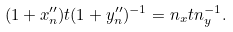Convert formula to latex. <formula><loc_0><loc_0><loc_500><loc_500>( 1 + x _ { n } ^ { \prime \prime } ) t ( 1 + y _ { n } ^ { \prime \prime } ) ^ { - 1 } = n _ { x } t n _ { y } ^ { - 1 } .</formula> 